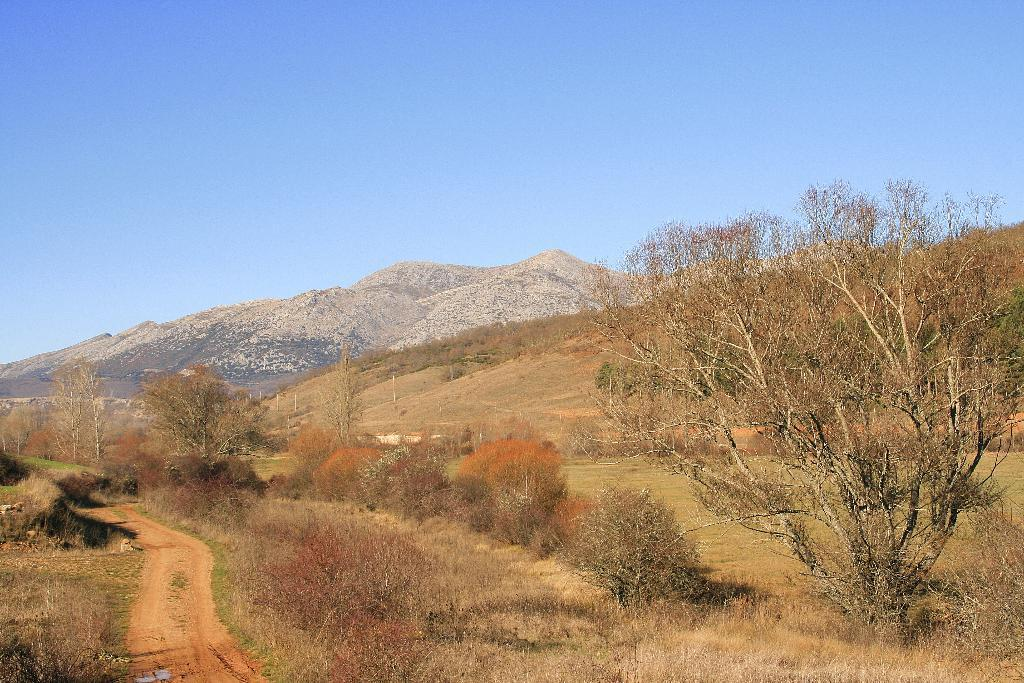What type of pathway is visible in the image? There is a road in the image. What type of vegetation can be seen in the image? There are trees, plants, and grass visible in the image. What type of elevated landforms are present in the image? There are hills in the image. What type of structures can be seen in the image? There are poles in the image. What part of the natural environment is visible in the image? The sky is visible in the image. What type of tank is visible in the image? There is no tank present in the image. What type of quilt is draped over the hills in the image? There is no quilt present in the image. 